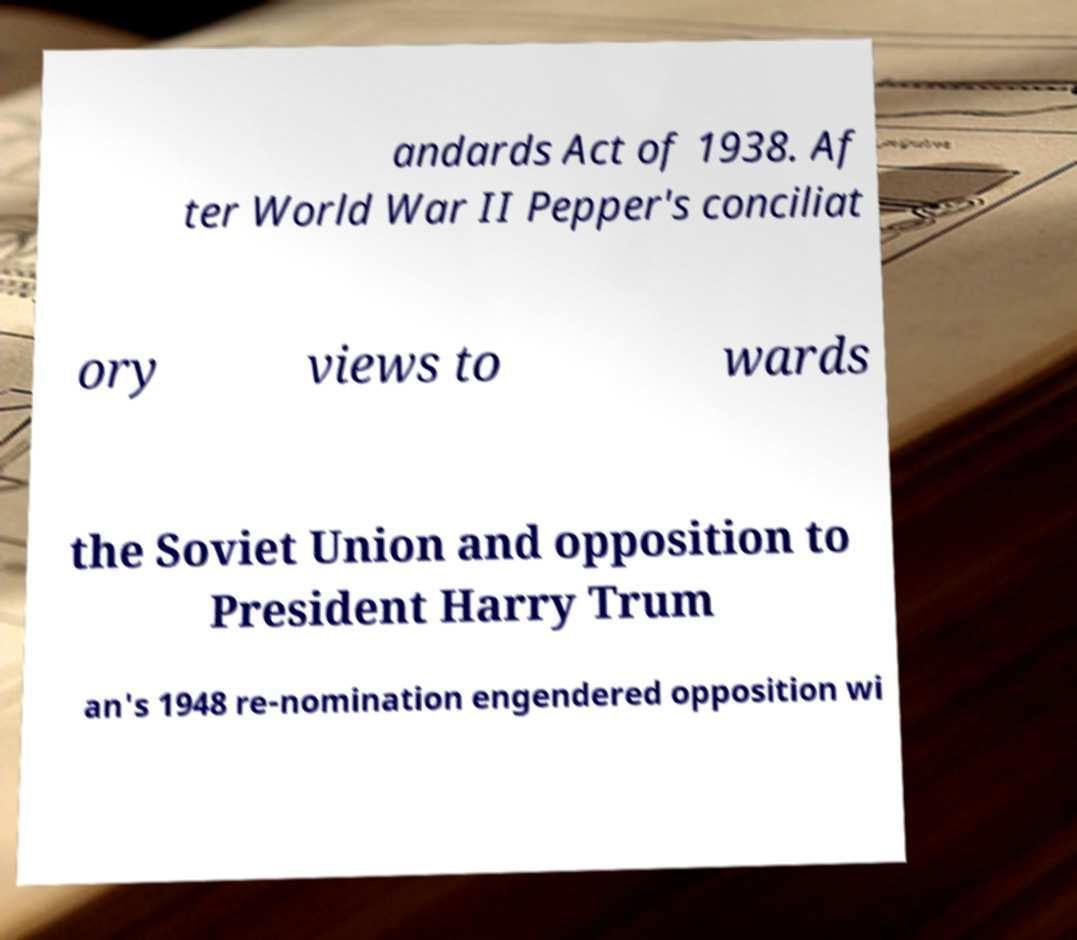Could you extract and type out the text from this image? andards Act of 1938. Af ter World War II Pepper's conciliat ory views to wards the Soviet Union and opposition to President Harry Trum an's 1948 re-nomination engendered opposition wi 